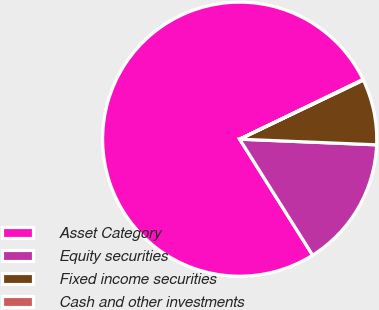<chart> <loc_0><loc_0><loc_500><loc_500><pie_chart><fcel>Asset Category<fcel>Equity securities<fcel>Fixed income securities<fcel>Cash and other investments<nl><fcel>76.76%<fcel>15.41%<fcel>7.75%<fcel>0.08%<nl></chart> 